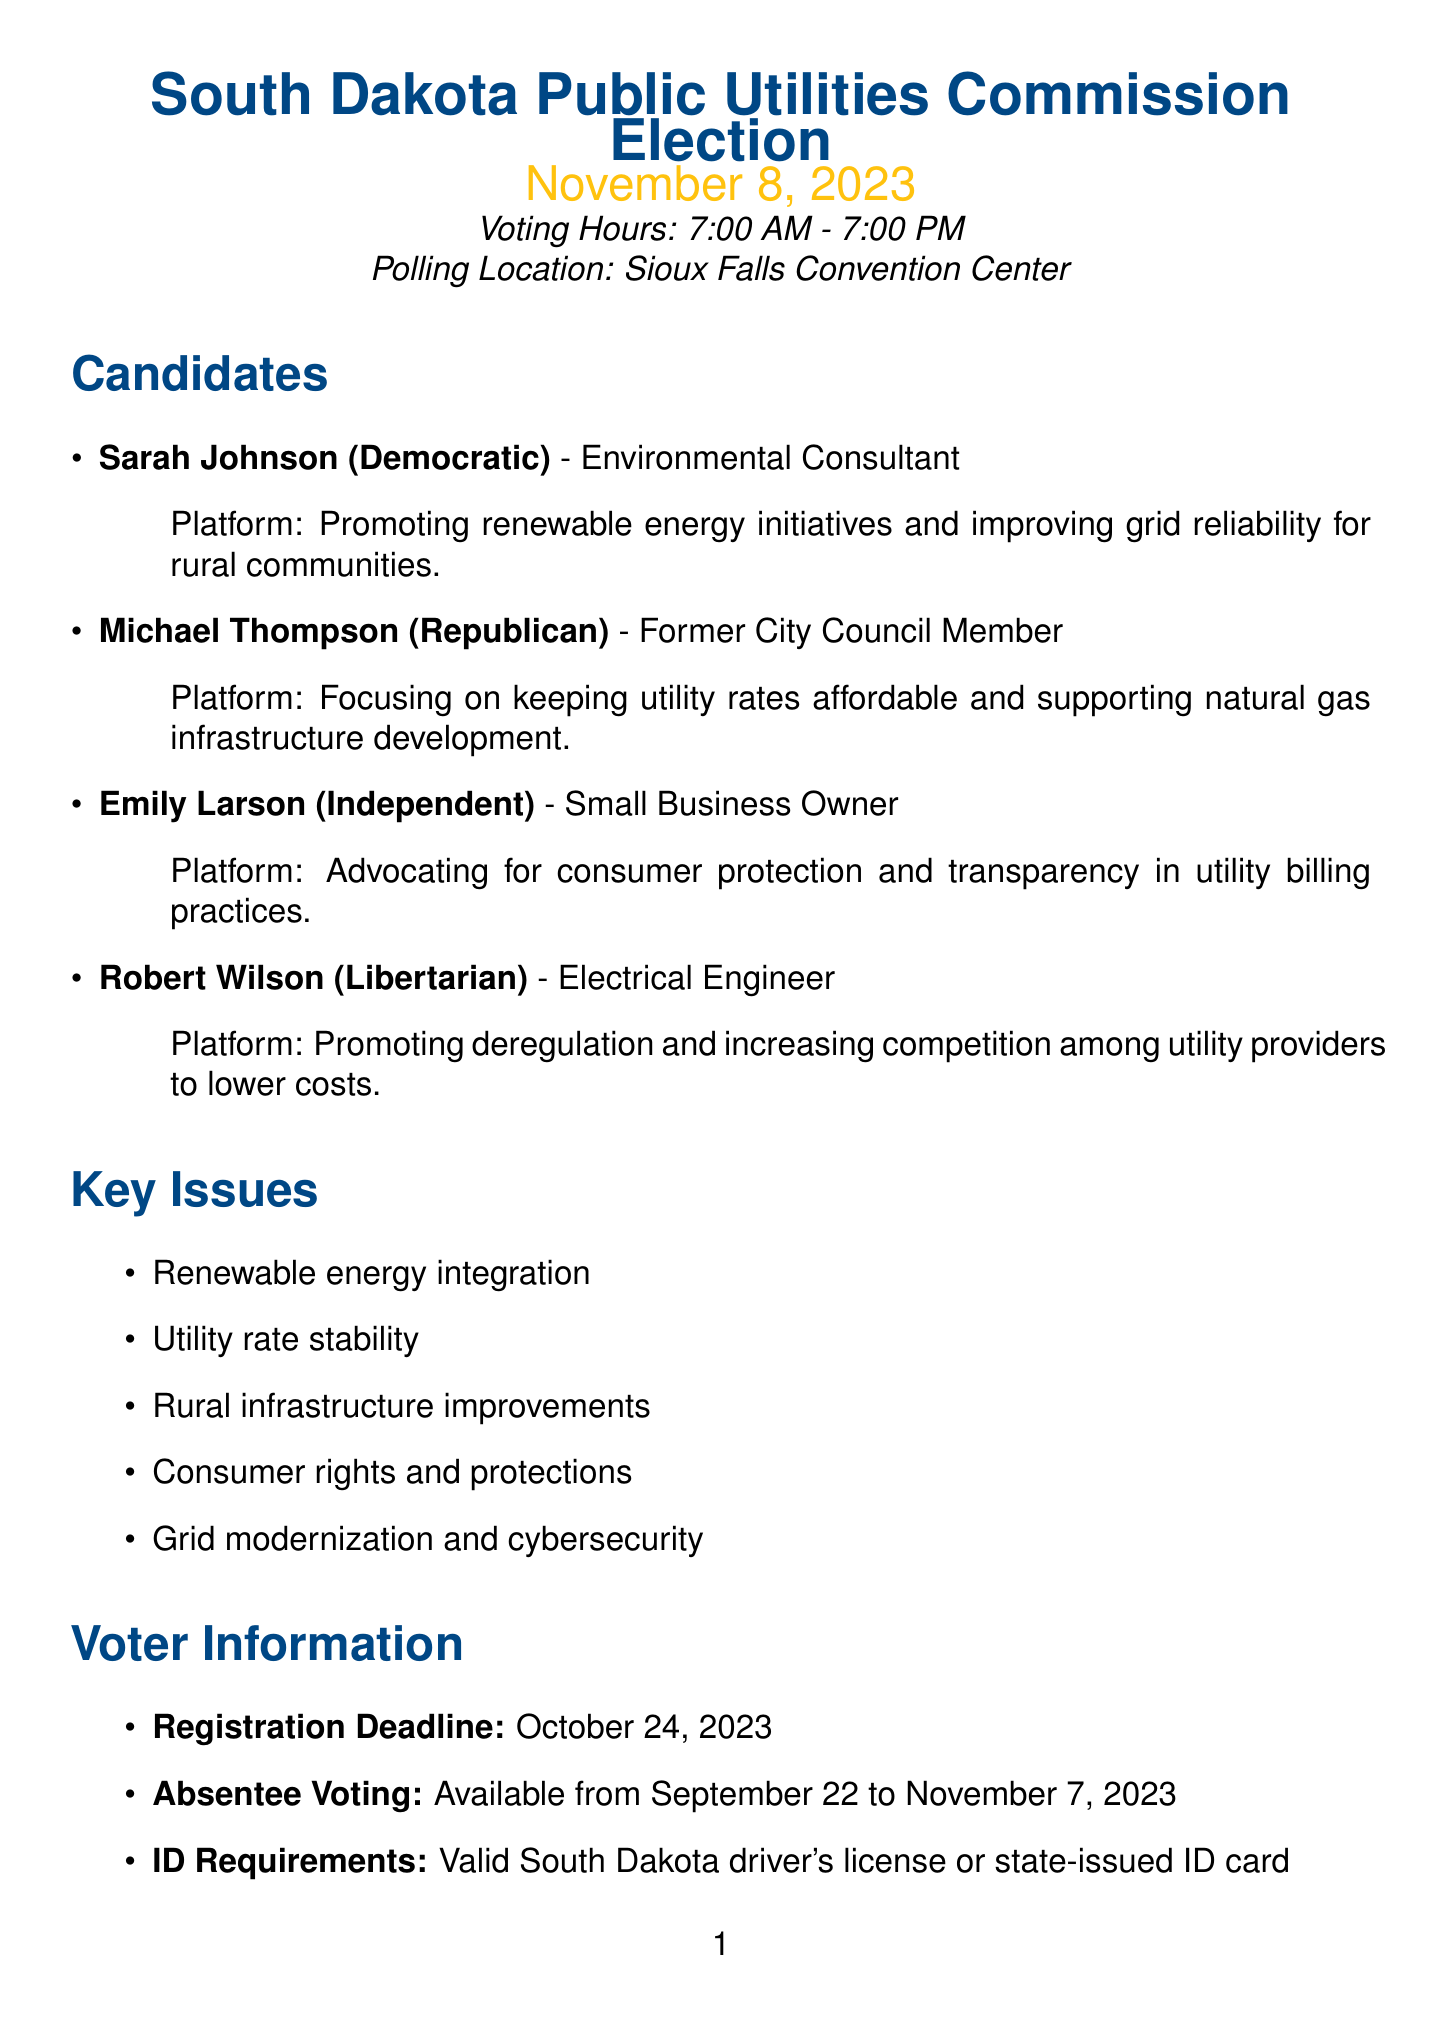What is the date of the election? The election date is explicitly stated in the document.
Answer: November 8, 2023 Where is the polling location? The polling location is clearly mentioned in the election details.
Answer: Sioux Falls Convention Center Who is the Democratic candidate? The document lists candidates along with their party affiliations.
Answer: Sarah Johnson What is Michael Thompson's platform focused on? The platform description provides insights into each candidate's priorities.
Answer: Keeping utility rates affordable What is the absentee voting period? The document outlines the timeline for absentee voting clearly.
Answer: September 22 to November 7, 2023 Which candidate is an Electrical Engineer? The candidate details include their current occupations.
Answer: Robert Wilson What key issue relates to consumer rights? The document lists key issues, including consumer-related topics.
Answer: Consumer rights and protections What is the registration deadline? The voter information section states the registration deadline.
Answer: October 24, 2023 When is the "Meet the Candidates" session? The community resources section provides dates for informational meetings.
Answer: October 12, 2023, 6:30 PM 